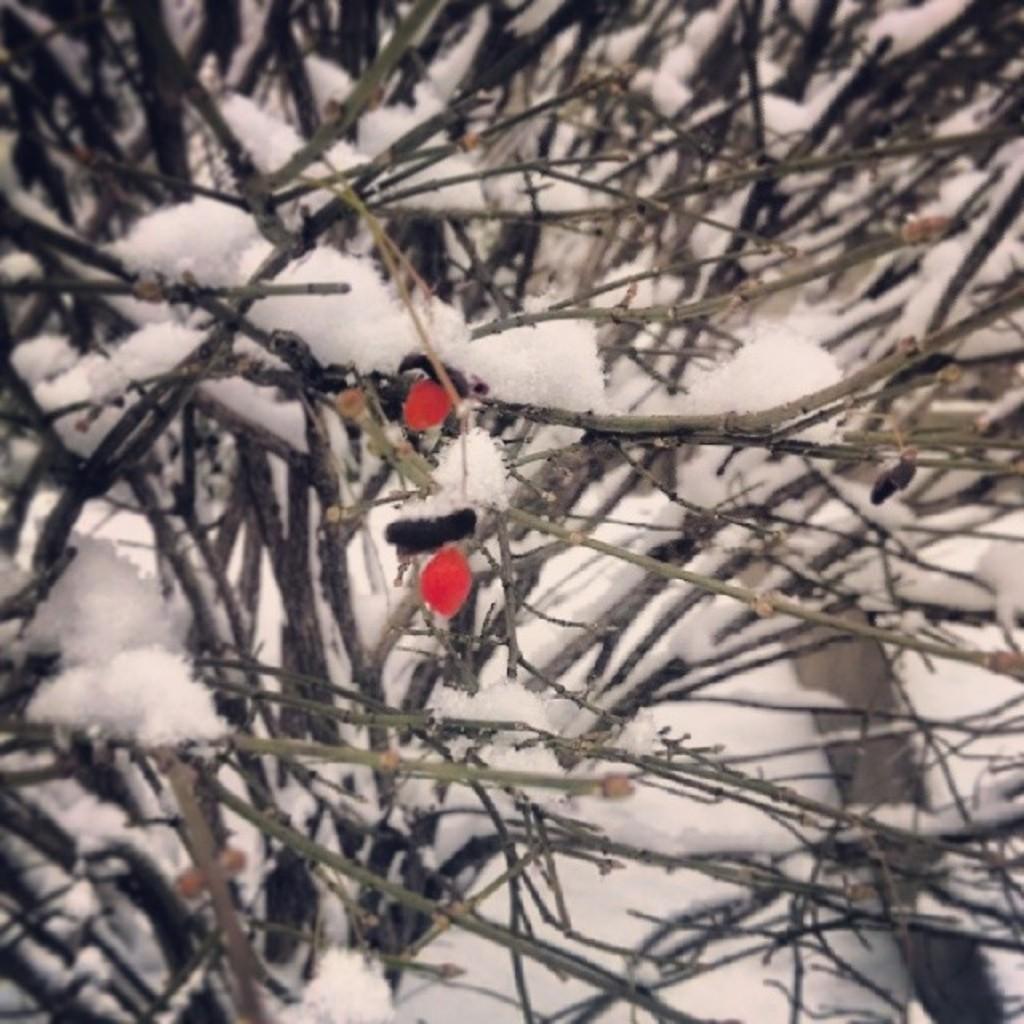Could you give a brief overview of what you see in this image? There are plants on which, there is snow. And the background is white in color. 